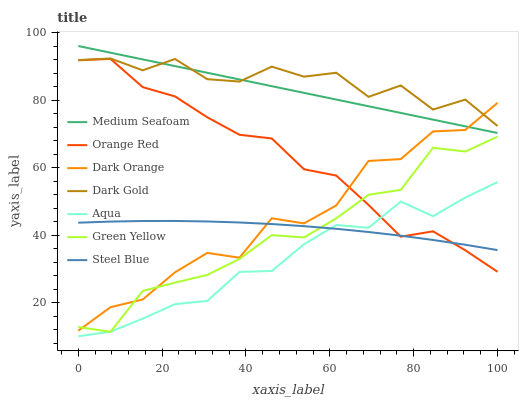Does Aqua have the minimum area under the curve?
Answer yes or no. Yes. Does Dark Gold have the maximum area under the curve?
Answer yes or no. Yes. Does Dark Gold have the minimum area under the curve?
Answer yes or no. No. Does Aqua have the maximum area under the curve?
Answer yes or no. No. Is Medium Seafoam the smoothest?
Answer yes or no. Yes. Is Dark Orange the roughest?
Answer yes or no. Yes. Is Dark Gold the smoothest?
Answer yes or no. No. Is Dark Gold the roughest?
Answer yes or no. No. Does Aqua have the lowest value?
Answer yes or no. Yes. Does Dark Gold have the lowest value?
Answer yes or no. No. Does Medium Seafoam have the highest value?
Answer yes or no. Yes. Does Dark Gold have the highest value?
Answer yes or no. No. Is Aqua less than Medium Seafoam?
Answer yes or no. Yes. Is Medium Seafoam greater than Aqua?
Answer yes or no. Yes. Does Dark Orange intersect Steel Blue?
Answer yes or no. Yes. Is Dark Orange less than Steel Blue?
Answer yes or no. No. Is Dark Orange greater than Steel Blue?
Answer yes or no. No. Does Aqua intersect Medium Seafoam?
Answer yes or no. No. 